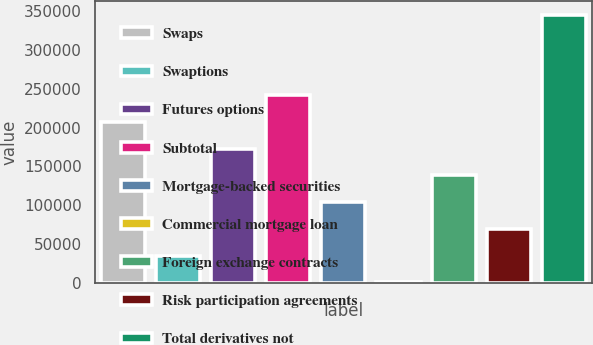<chart> <loc_0><loc_0><loc_500><loc_500><bar_chart><fcel>Swaps<fcel>Swaptions<fcel>Futures options<fcel>Subtotal<fcel>Mortgage-backed securities<fcel>Commercial mortgage loan<fcel>Foreign exchange contracts<fcel>Risk participation agreements<fcel>Total derivatives not<nl><fcel>207305<fcel>35111.6<fcel>172866<fcel>241743<fcel>103989<fcel>673<fcel>138427<fcel>69550.2<fcel>345059<nl></chart> 